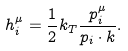<formula> <loc_0><loc_0><loc_500><loc_500>h _ { i } ^ { \mu } = \frac { 1 } { 2 } k _ { T } \frac { p _ { i } ^ { \mu } } { p _ { i } \cdot k } .</formula> 